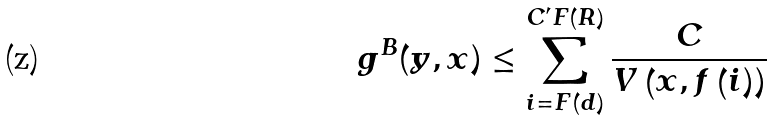<formula> <loc_0><loc_0><loc_500><loc_500>g ^ { B } ( y , x ) \leq \sum _ { i = F ( d ) } ^ { C ^ { \prime } F \left ( R \right ) } \frac { C } { V \left ( x , f \left ( i \right ) \right ) }</formula> 